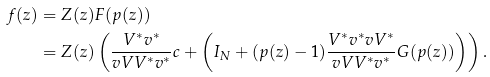<formula> <loc_0><loc_0><loc_500><loc_500>f ( z ) & = Z ( z ) F ( p ( z ) ) \\ & = Z ( z ) \left ( \frac { V ^ { * } v ^ { * } } { v V V ^ { * } v ^ { * } } c + \left ( I _ { N } + ( p ( z ) - 1 ) \frac { V ^ { * } v ^ { * } v V ^ { * } } { v V V ^ { * } v ^ { * } } G ( p ( z ) ) \right ) \right ) .</formula> 